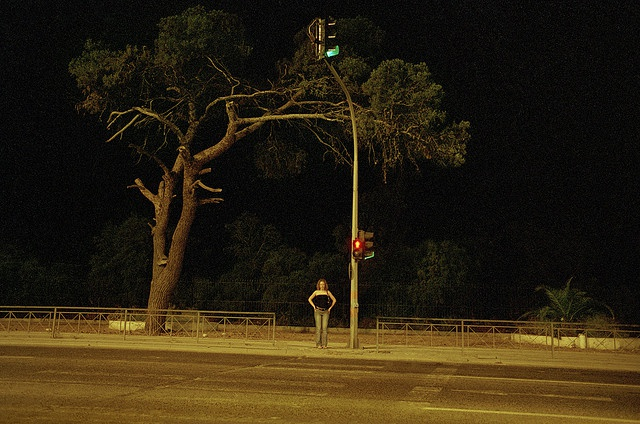Describe the objects in this image and their specific colors. I can see people in black, olive, and maroon tones, traffic light in black, olive, and green tones, traffic light in black, maroon, olive, and brown tones, traffic light in black, maroon, and olive tones, and traffic light in black, maroon, and red tones in this image. 